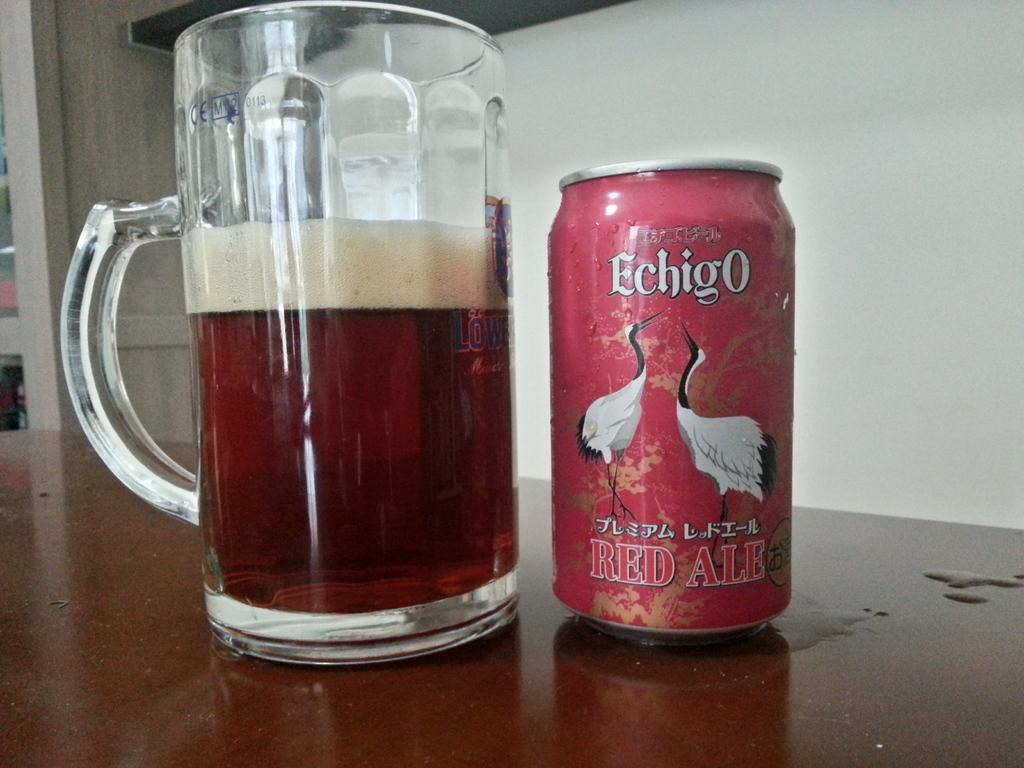What is the name of the beverage?
Make the answer very short. Echigo. 